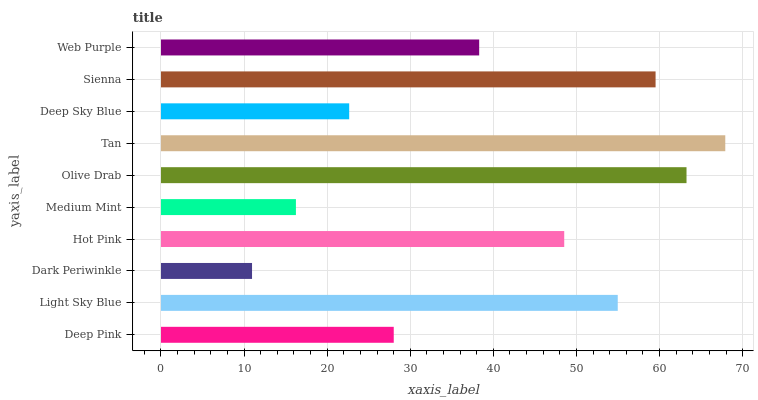Is Dark Periwinkle the minimum?
Answer yes or no. Yes. Is Tan the maximum?
Answer yes or no. Yes. Is Light Sky Blue the minimum?
Answer yes or no. No. Is Light Sky Blue the maximum?
Answer yes or no. No. Is Light Sky Blue greater than Deep Pink?
Answer yes or no. Yes. Is Deep Pink less than Light Sky Blue?
Answer yes or no. Yes. Is Deep Pink greater than Light Sky Blue?
Answer yes or no. No. Is Light Sky Blue less than Deep Pink?
Answer yes or no. No. Is Hot Pink the high median?
Answer yes or no. Yes. Is Web Purple the low median?
Answer yes or no. Yes. Is Web Purple the high median?
Answer yes or no. No. Is Tan the low median?
Answer yes or no. No. 